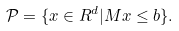Convert formula to latex. <formula><loc_0><loc_0><loc_500><loc_500>\mathcal { P } = \{ x \in R ^ { d } | M x \leq b \} .</formula> 